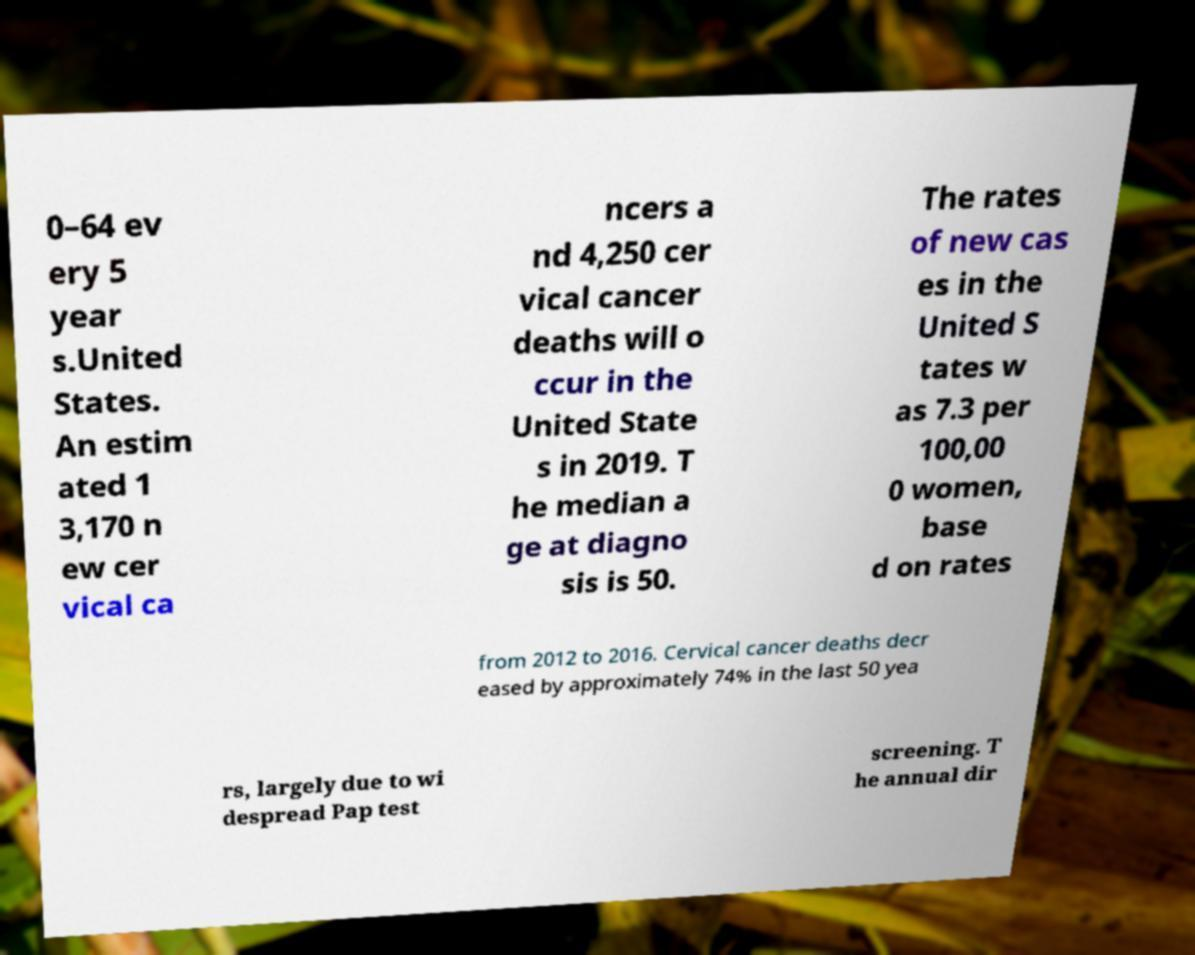Please read and relay the text visible in this image. What does it say? 0–64 ev ery 5 year s.United States. An estim ated 1 3,170 n ew cer vical ca ncers a nd 4,250 cer vical cancer deaths will o ccur in the United State s in 2019. T he median a ge at diagno sis is 50. The rates of new cas es in the United S tates w as 7.3 per 100,00 0 women, base d on rates from 2012 to 2016. Cervical cancer deaths decr eased by approximately 74% in the last 50 yea rs, largely due to wi despread Pap test screening. T he annual dir 